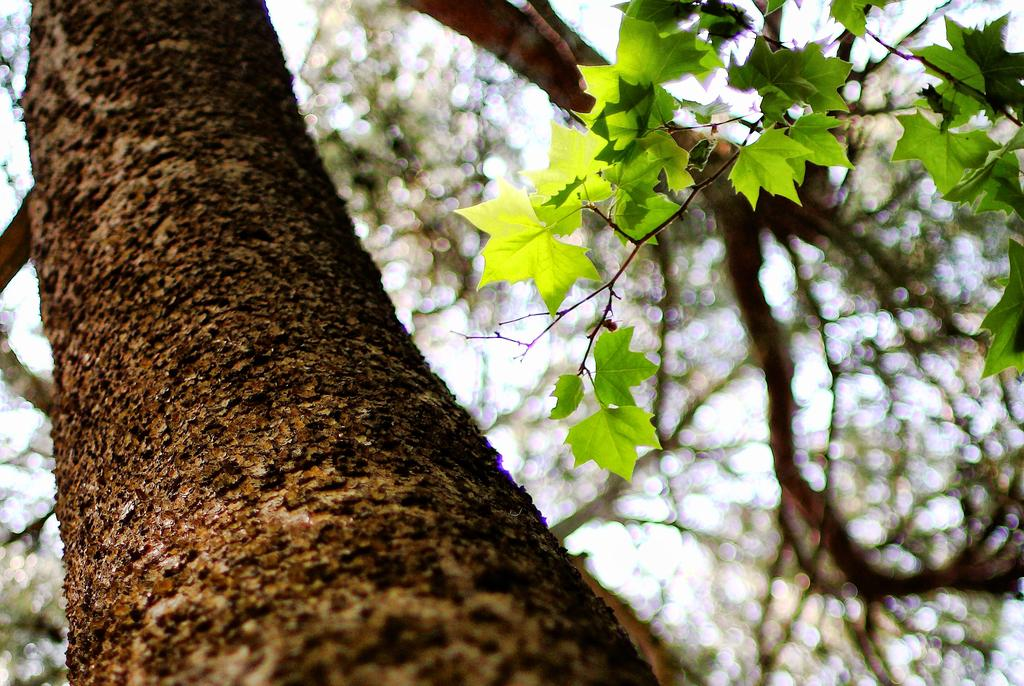What type of plant can be seen in the image? There is a tree in the image. What features can be observed on the tree? The tree has leaves and branches. What is visible in the background of the image? The sky is visible in the image. Can you see any steam coming from the middle of the tree in the image? There is no steam present in the image, and the tree is not depicted as emitting steam. 